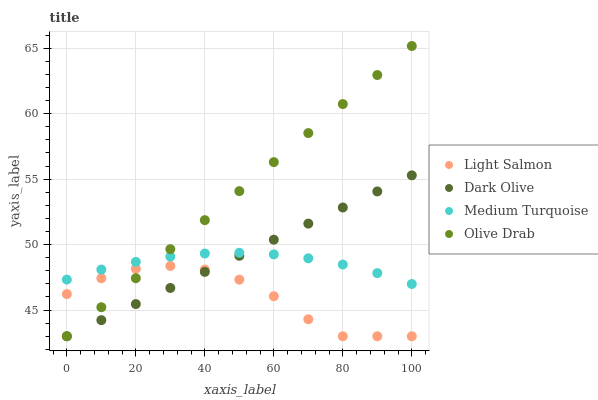Does Light Salmon have the minimum area under the curve?
Answer yes or no. Yes. Does Olive Drab have the maximum area under the curve?
Answer yes or no. Yes. Does Dark Olive have the minimum area under the curve?
Answer yes or no. No. Does Dark Olive have the maximum area under the curve?
Answer yes or no. No. Is Olive Drab the smoothest?
Answer yes or no. Yes. Is Light Salmon the roughest?
Answer yes or no. Yes. Is Dark Olive the smoothest?
Answer yes or no. No. Is Dark Olive the roughest?
Answer yes or no. No. Does Light Salmon have the lowest value?
Answer yes or no. Yes. Does Medium Turquoise have the lowest value?
Answer yes or no. No. Does Olive Drab have the highest value?
Answer yes or no. Yes. Does Dark Olive have the highest value?
Answer yes or no. No. Is Light Salmon less than Medium Turquoise?
Answer yes or no. Yes. Is Medium Turquoise greater than Light Salmon?
Answer yes or no. Yes. Does Dark Olive intersect Medium Turquoise?
Answer yes or no. Yes. Is Dark Olive less than Medium Turquoise?
Answer yes or no. No. Is Dark Olive greater than Medium Turquoise?
Answer yes or no. No. Does Light Salmon intersect Medium Turquoise?
Answer yes or no. No. 